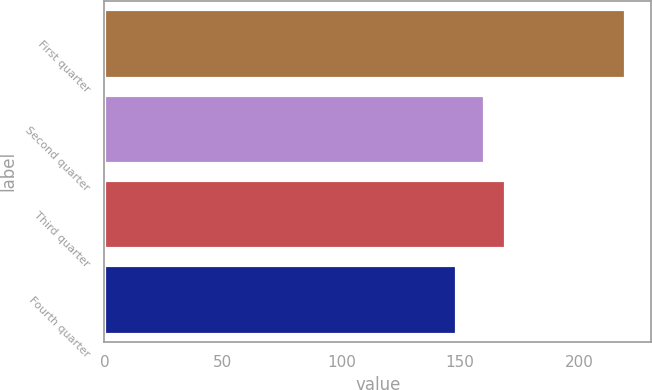Convert chart. <chart><loc_0><loc_0><loc_500><loc_500><bar_chart><fcel>First quarter<fcel>Second quarter<fcel>Third quarter<fcel>Fourth quarter<nl><fcel>219.51<fcel>160.1<fcel>169<fcel>148.29<nl></chart> 